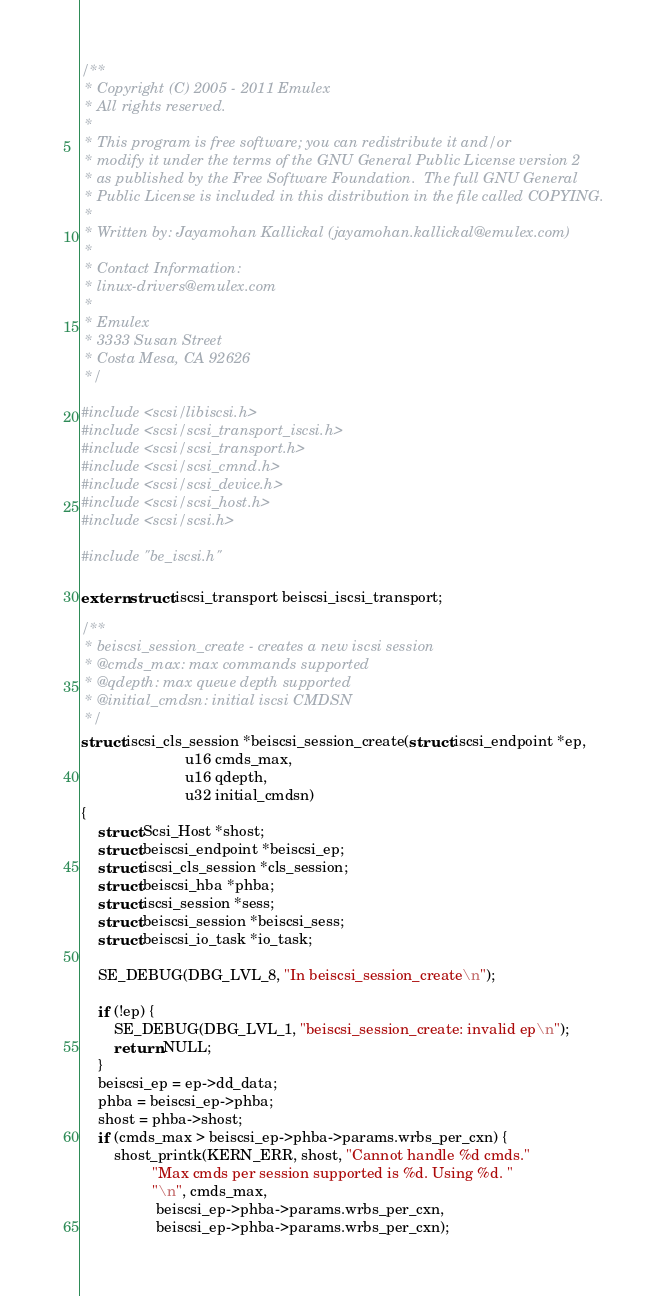<code> <loc_0><loc_0><loc_500><loc_500><_C_>/**
 * Copyright (C) 2005 - 2011 Emulex
 * All rights reserved.
 *
 * This program is free software; you can redistribute it and/or
 * modify it under the terms of the GNU General Public License version 2
 * as published by the Free Software Foundation.  The full GNU General
 * Public License is included in this distribution in the file called COPYING.
 *
 * Written by: Jayamohan Kallickal (jayamohan.kallickal@emulex.com)
 *
 * Contact Information:
 * linux-drivers@emulex.com
 *
 * Emulex
 * 3333 Susan Street
 * Costa Mesa, CA 92626
 */

#include <scsi/libiscsi.h>
#include <scsi/scsi_transport_iscsi.h>
#include <scsi/scsi_transport.h>
#include <scsi/scsi_cmnd.h>
#include <scsi/scsi_device.h>
#include <scsi/scsi_host.h>
#include <scsi/scsi.h>

#include "be_iscsi.h"

extern struct iscsi_transport beiscsi_iscsi_transport;

/**
 * beiscsi_session_create - creates a new iscsi session
 * @cmds_max: max commands supported
 * @qdepth: max queue depth supported
 * @initial_cmdsn: initial iscsi CMDSN
 */
struct iscsi_cls_session *beiscsi_session_create(struct iscsi_endpoint *ep,
						 u16 cmds_max,
						 u16 qdepth,
						 u32 initial_cmdsn)
{
	struct Scsi_Host *shost;
	struct beiscsi_endpoint *beiscsi_ep;
	struct iscsi_cls_session *cls_session;
	struct beiscsi_hba *phba;
	struct iscsi_session *sess;
	struct beiscsi_session *beiscsi_sess;
	struct beiscsi_io_task *io_task;

	SE_DEBUG(DBG_LVL_8, "In beiscsi_session_create\n");

	if (!ep) {
		SE_DEBUG(DBG_LVL_1, "beiscsi_session_create: invalid ep\n");
		return NULL;
	}
	beiscsi_ep = ep->dd_data;
	phba = beiscsi_ep->phba;
	shost = phba->shost;
	if (cmds_max > beiscsi_ep->phba->params.wrbs_per_cxn) {
		shost_printk(KERN_ERR, shost, "Cannot handle %d cmds."
			     "Max cmds per session supported is %d. Using %d. "
			     "\n", cmds_max,
			      beiscsi_ep->phba->params.wrbs_per_cxn,
			      beiscsi_ep->phba->params.wrbs_per_cxn);</code> 